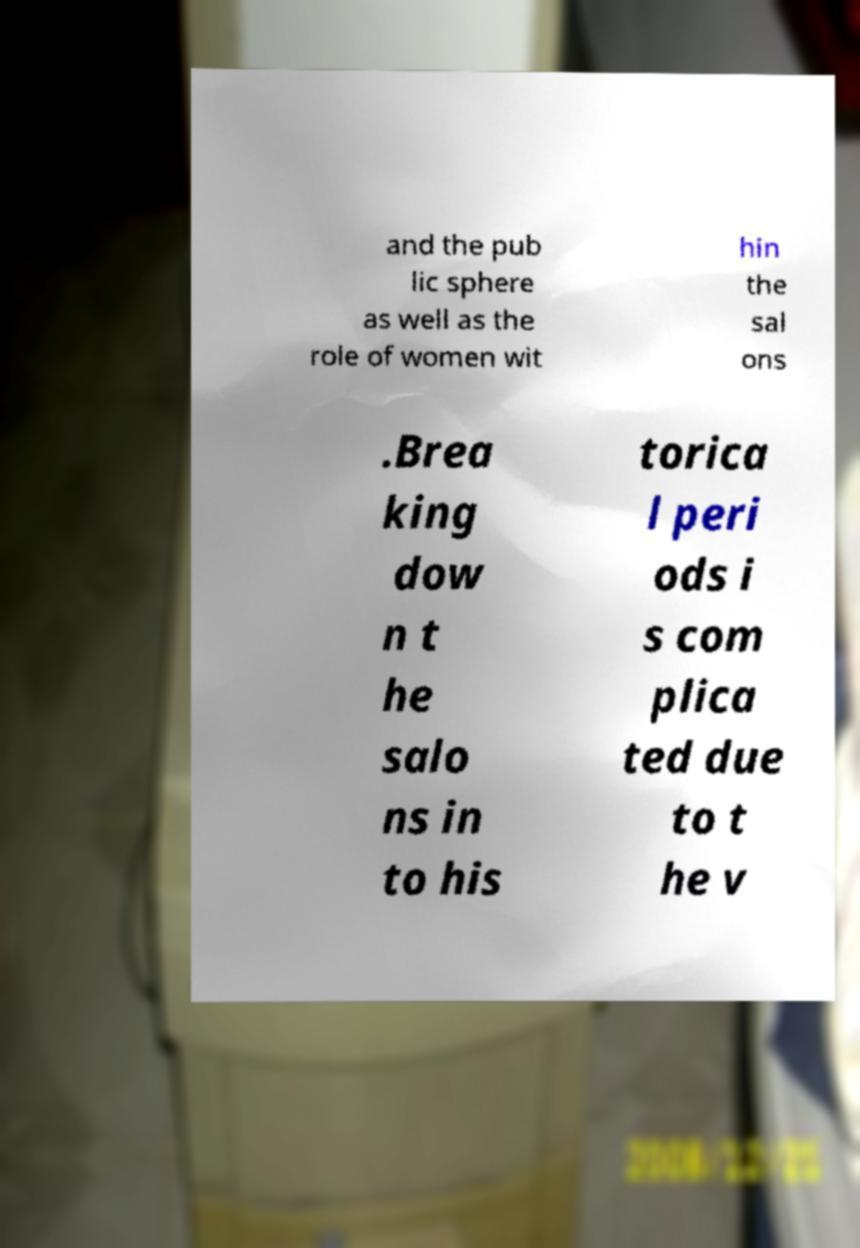There's text embedded in this image that I need extracted. Can you transcribe it verbatim? and the pub lic sphere as well as the role of women wit hin the sal ons .Brea king dow n t he salo ns in to his torica l peri ods i s com plica ted due to t he v 